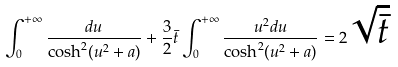Convert formula to latex. <formula><loc_0><loc_0><loc_500><loc_500>\int _ { 0 } ^ { + \infty } \frac { d u } { \cosh ^ { 2 } ( u ^ { 2 } + a ) } + \frac { 3 } { 2 } \bar { t } \int _ { 0 } ^ { + \infty } \frac { u ^ { 2 } d u } { \cosh ^ { 2 } ( u ^ { 2 } + a ) } = 2 \sqrt { \bar { t } }</formula> 